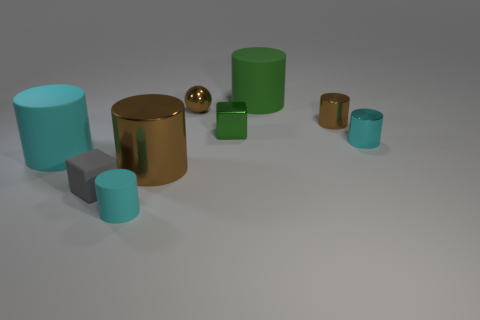Subtract all gray cubes. How many cyan cylinders are left? 3 Subtract 2 cylinders. How many cylinders are left? 4 Subtract all tiny shiny cylinders. How many cylinders are left? 4 Subtract all brown cylinders. How many cylinders are left? 4 Subtract all gray cylinders. Subtract all gray balls. How many cylinders are left? 6 Add 1 brown spheres. How many objects exist? 10 Subtract all cubes. How many objects are left? 7 Add 2 cyan rubber cylinders. How many cyan rubber cylinders are left? 4 Add 6 tiny brown metal things. How many tiny brown metal things exist? 8 Subtract 1 green cylinders. How many objects are left? 8 